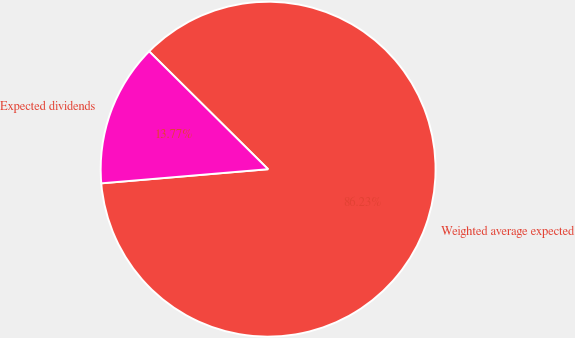Convert chart to OTSL. <chart><loc_0><loc_0><loc_500><loc_500><pie_chart><fcel>Weighted average expected<fcel>Expected dividends<nl><fcel>86.23%<fcel>13.77%<nl></chart> 